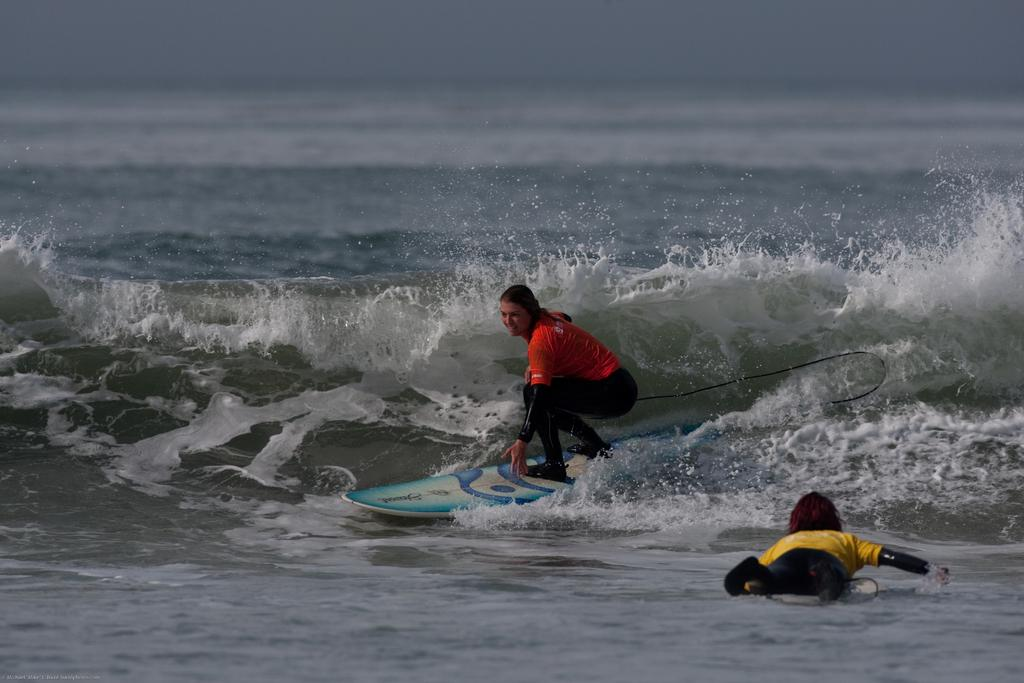How many people are in the image? There are two persons in the image. What are the two persons doing in the image? The two persons are surfing. Where is the surfing taking place? The surfing is taking place on a sea. What type of jar can be seen floating near the surfers in the image? There is no jar present in the image; the two persons are surfing on a sea. 